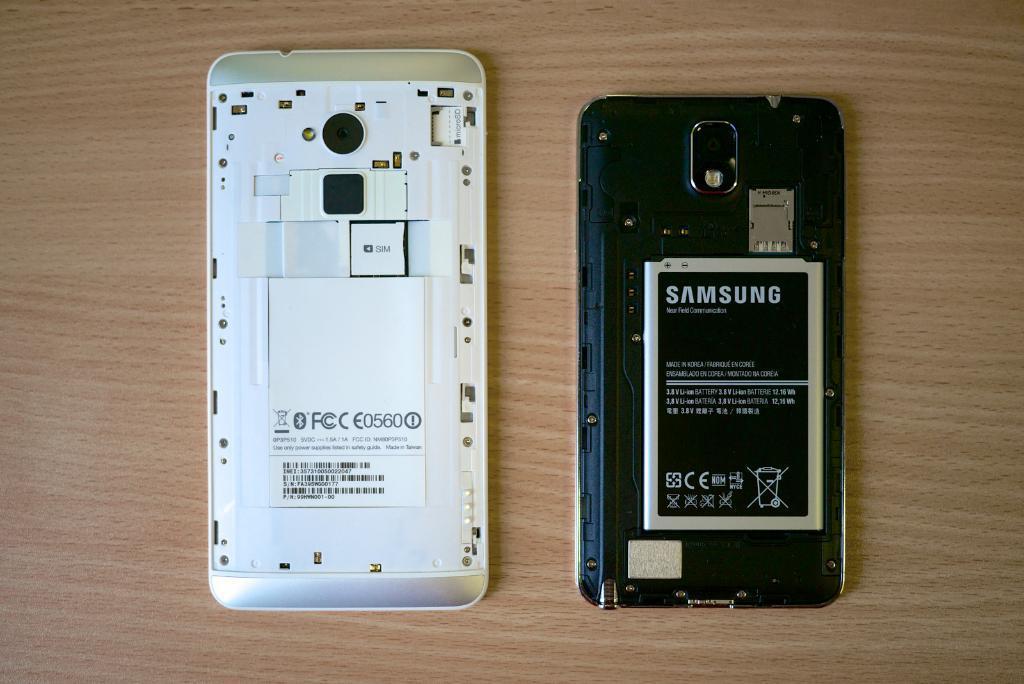How would you summarize this image in a sentence or two? In this picture we can see two mobiles with batteries on a table. 